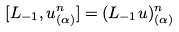<formula> <loc_0><loc_0><loc_500><loc_500>[ L _ { - 1 } , u _ { ( \alpha ) } ^ { n } ] = ( L _ { - 1 } u ) _ { ( \alpha ) } ^ { n }</formula> 